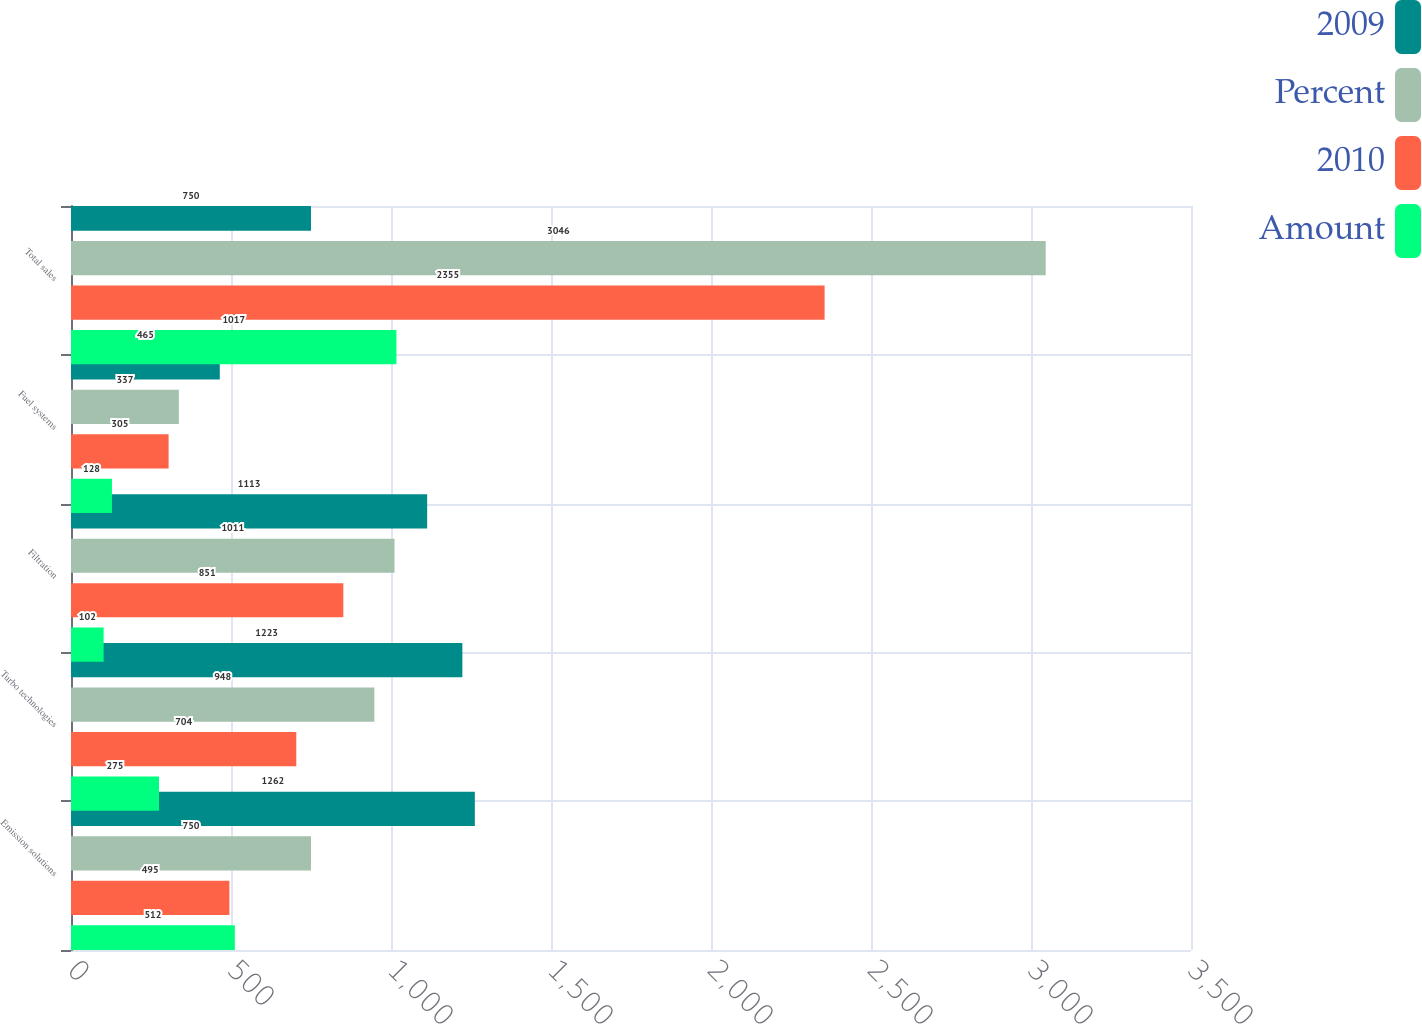<chart> <loc_0><loc_0><loc_500><loc_500><stacked_bar_chart><ecel><fcel>Emission solutions<fcel>Turbo technologies<fcel>Filtration<fcel>Fuel systems<fcel>Total sales<nl><fcel>2009<fcel>1262<fcel>1223<fcel>1113<fcel>465<fcel>750<nl><fcel>Percent<fcel>750<fcel>948<fcel>1011<fcel>337<fcel>3046<nl><fcel>2010<fcel>495<fcel>704<fcel>851<fcel>305<fcel>2355<nl><fcel>Amount<fcel>512<fcel>275<fcel>102<fcel>128<fcel>1017<nl></chart> 